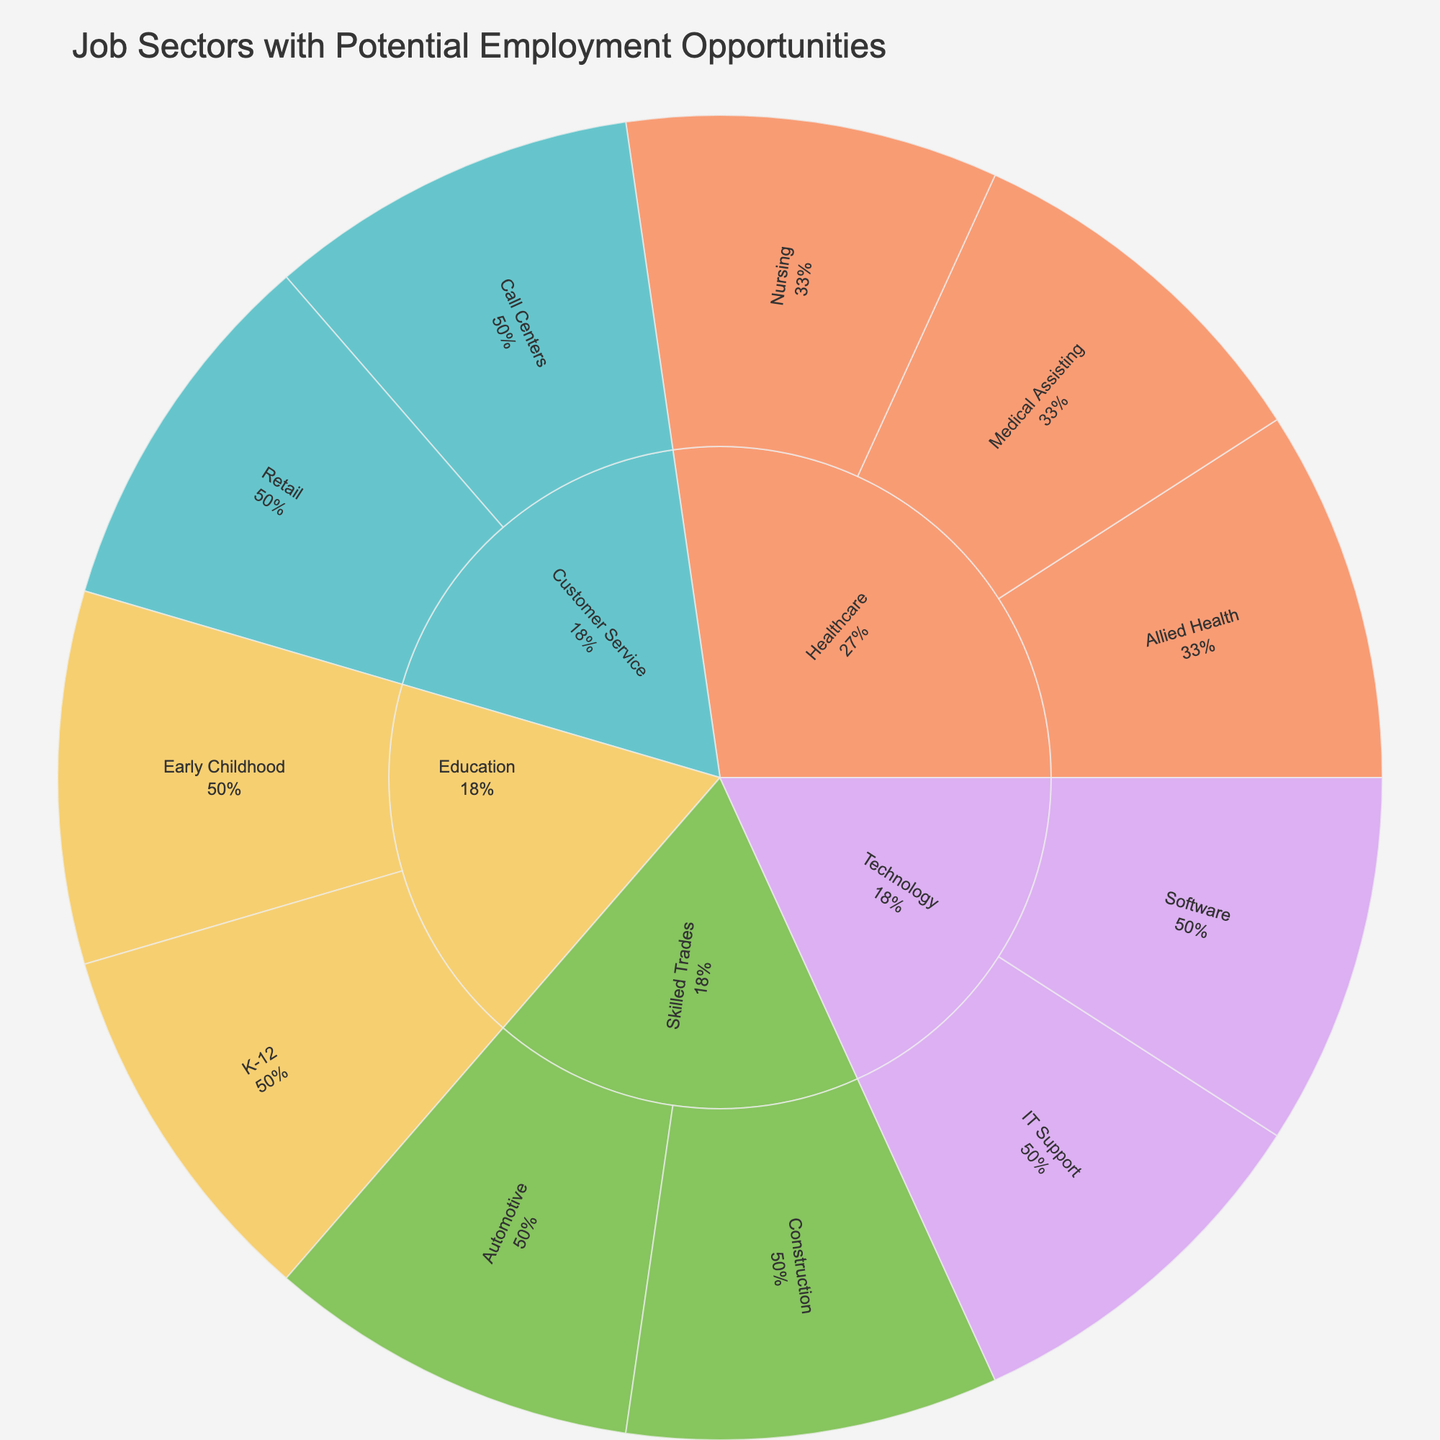What is the title of the figure? The title of the figure is usually displayed at the top of a plot
Answer: Job Sectors with Potential Employment Opportunities What sector has the "Preschool Teacher" role? To find the sector, follow the path from the "Preschool Teacher" job to its subsector and then to its sector
Answer: Education Which subsectors belong to the Healthcare sector? Identify the subsectors that are directly beneath the Healthcare sector in the hierarchy
Answer: Nursing, Medical Assisting, Allied Health Are there more job roles in the Technology sector or in the Skilled Trades sector? Count the job roles within the Technology and Skilled Trades sectors in the figure
Answer: Technology Which job role in the IT Support subsector has more employment opportunities than the other? While the exact percentage isn't shown, generally, the larger segment in this subsector will indicate more opportunities
Answer: Help Desk Technician (if represented by a larger segment) How many job roles are there in the Customer Service sector? Sum up all job roles indicated under the Customer Service sector
Answer: 4 Which subsector under Healthcare has more job roles, Nursing or Allied Health? Compare the number of job roles listed under Nursing and Allied Health subsectors in the Healthcare sector
Answer: Nursing Which job role in the Call Centers subsector has fewer employment opportunities? Compare the sizes of the segments representing job roles within Call Centers
Answer: Technical Support Agent (if represented by a smaller segment) What percentage of the Technology sector is dedicated to Software jobs? Find the percentage of the Software subsector within the Technology sector as represented in the figure
Answer: (specific value shown within the plot, for instance: 50%) Are there any job roles listed under both Medical Assisting and IT Support? Check if any job role appears in both the Medical Assisting and IT Support subsectors
Answer: No 